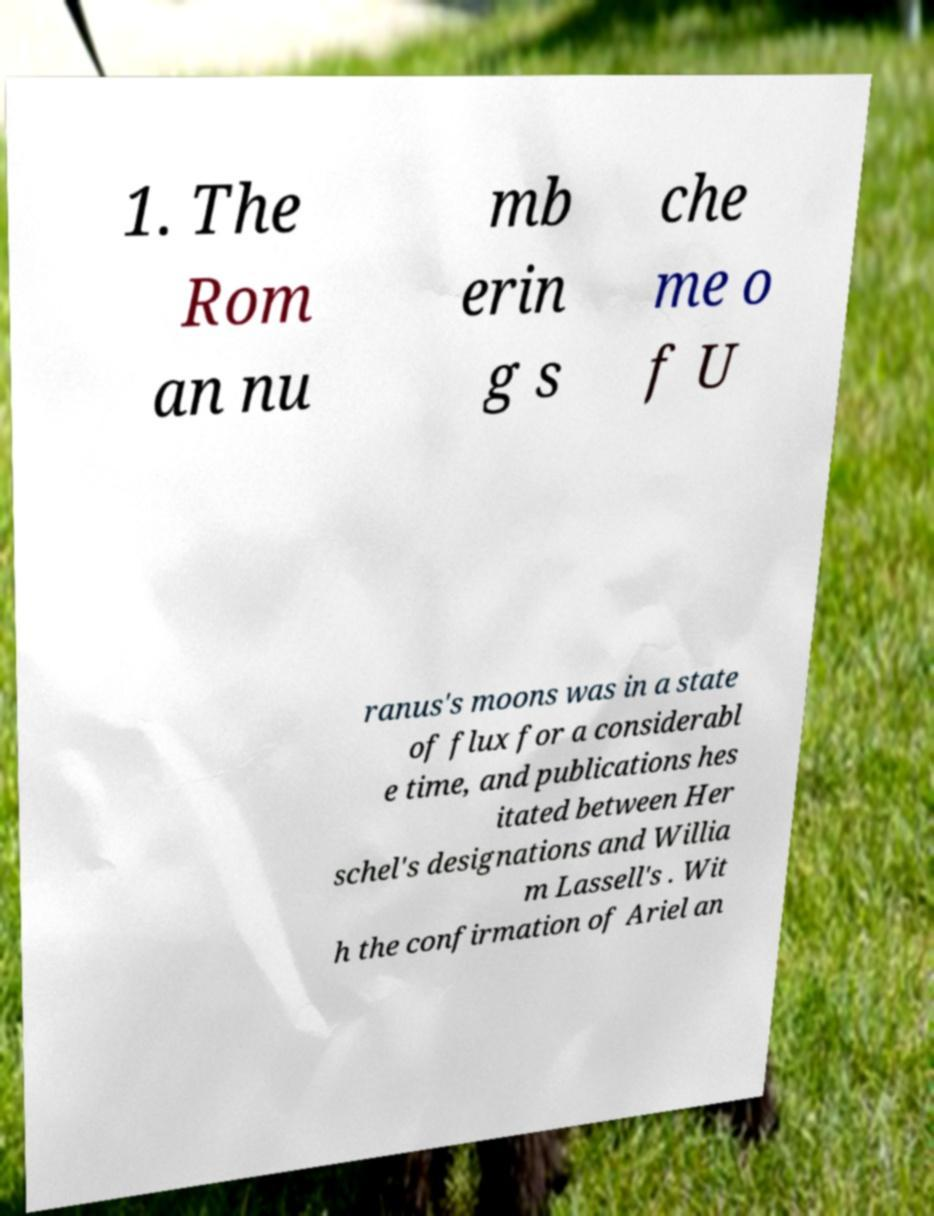Can you read and provide the text displayed in the image?This photo seems to have some interesting text. Can you extract and type it out for me? 1. The Rom an nu mb erin g s che me o f U ranus's moons was in a state of flux for a considerabl e time, and publications hes itated between Her schel's designations and Willia m Lassell's . Wit h the confirmation of Ariel an 